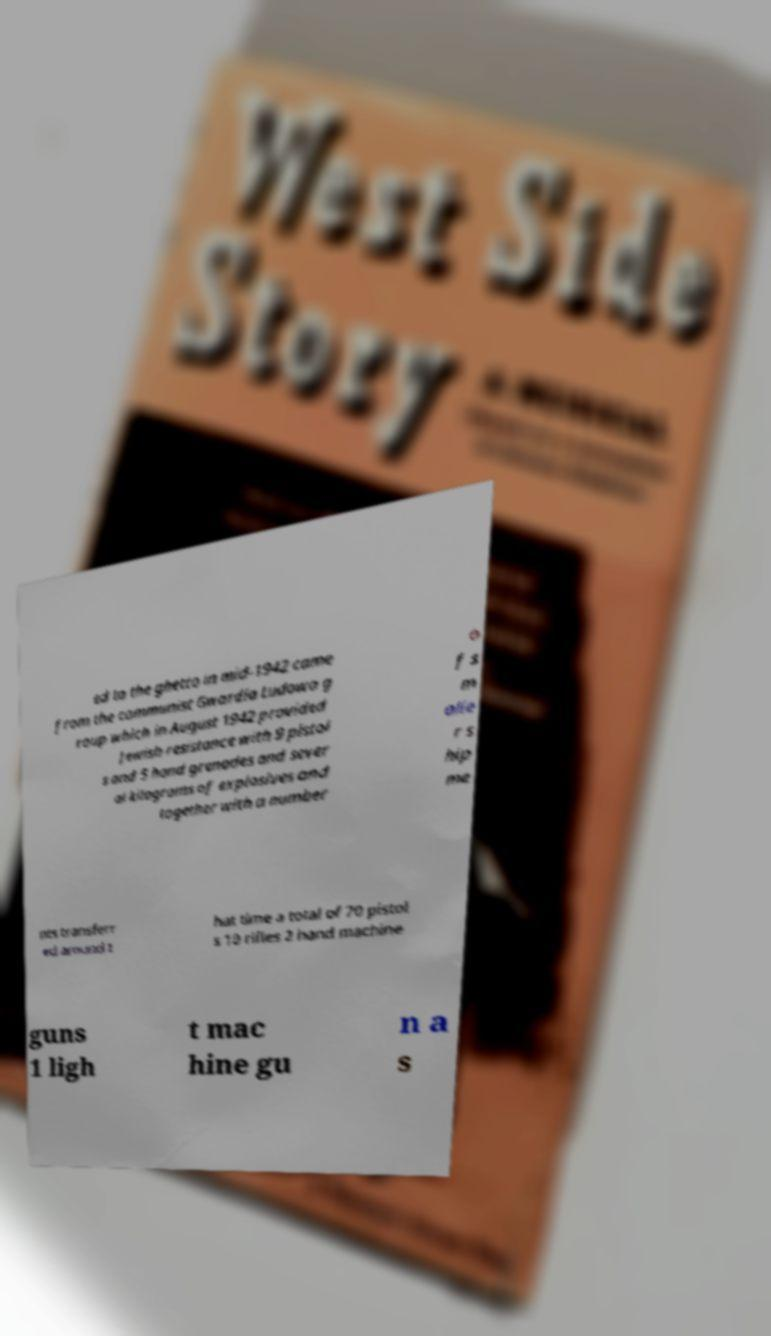I need the written content from this picture converted into text. Can you do that? ed to the ghetto in mid-1942 came from the communist Gwardia Ludowa g roup which in August 1942 provided Jewish resistance with 9 pistol s and 5 hand grenades and sever al kilograms of explosives and together with a number o f s m alle r s hip me nts transferr ed around t hat time a total of 70 pistol s 10 rifles 2 hand machine guns 1 ligh t mac hine gu n a s 